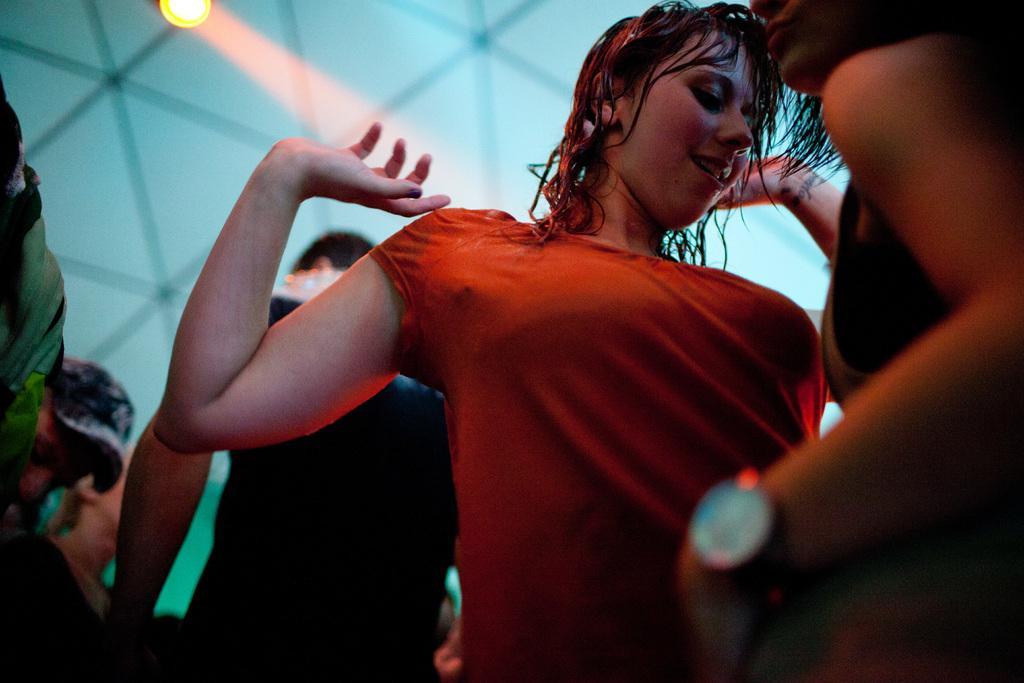Please provide a concise description of this image. Here I can see few people. It seems like they are dancing. In the background it seems to be a wall. At the top of the image there is a light. 